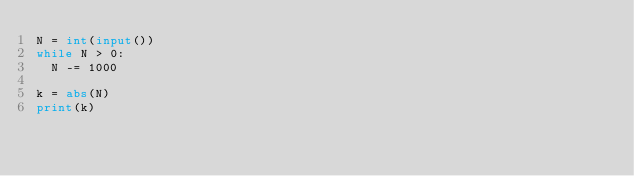Convert code to text. <code><loc_0><loc_0><loc_500><loc_500><_Python_>N = int(input())
while N > 0:
  N -= 1000 

k = abs(N)
print(k)</code> 